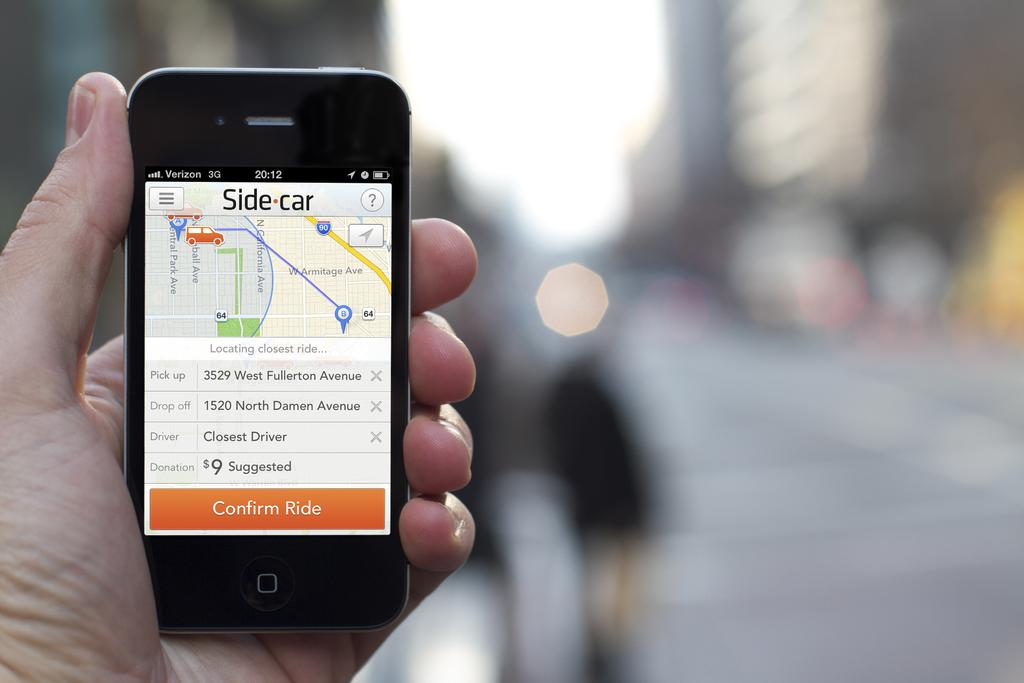<image>
Summarize the visual content of the image. a phone that has the words confirm ride on it 